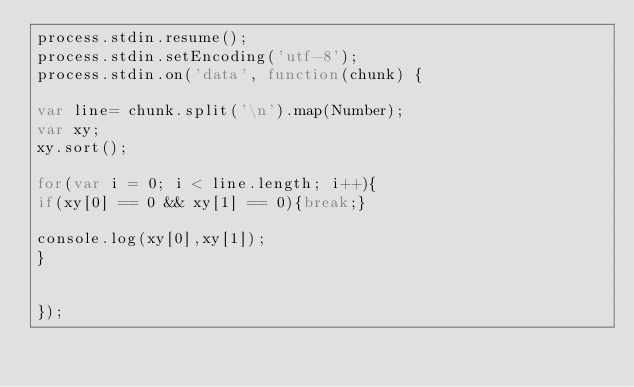Convert code to text. <code><loc_0><loc_0><loc_500><loc_500><_JavaScript_>process.stdin.resume();
process.stdin.setEncoding('utf-8');
process.stdin.on('data', function(chunk) {
 
var line= chunk.split('\n').map(Number);
var xy;
xy.sort();

for(var i = 0; i < line.length; i++){
if(xy[0] == 0 && xy[1] == 0){break;}

console.log(xy[0],xy[1]);
}
 
 
});</code> 